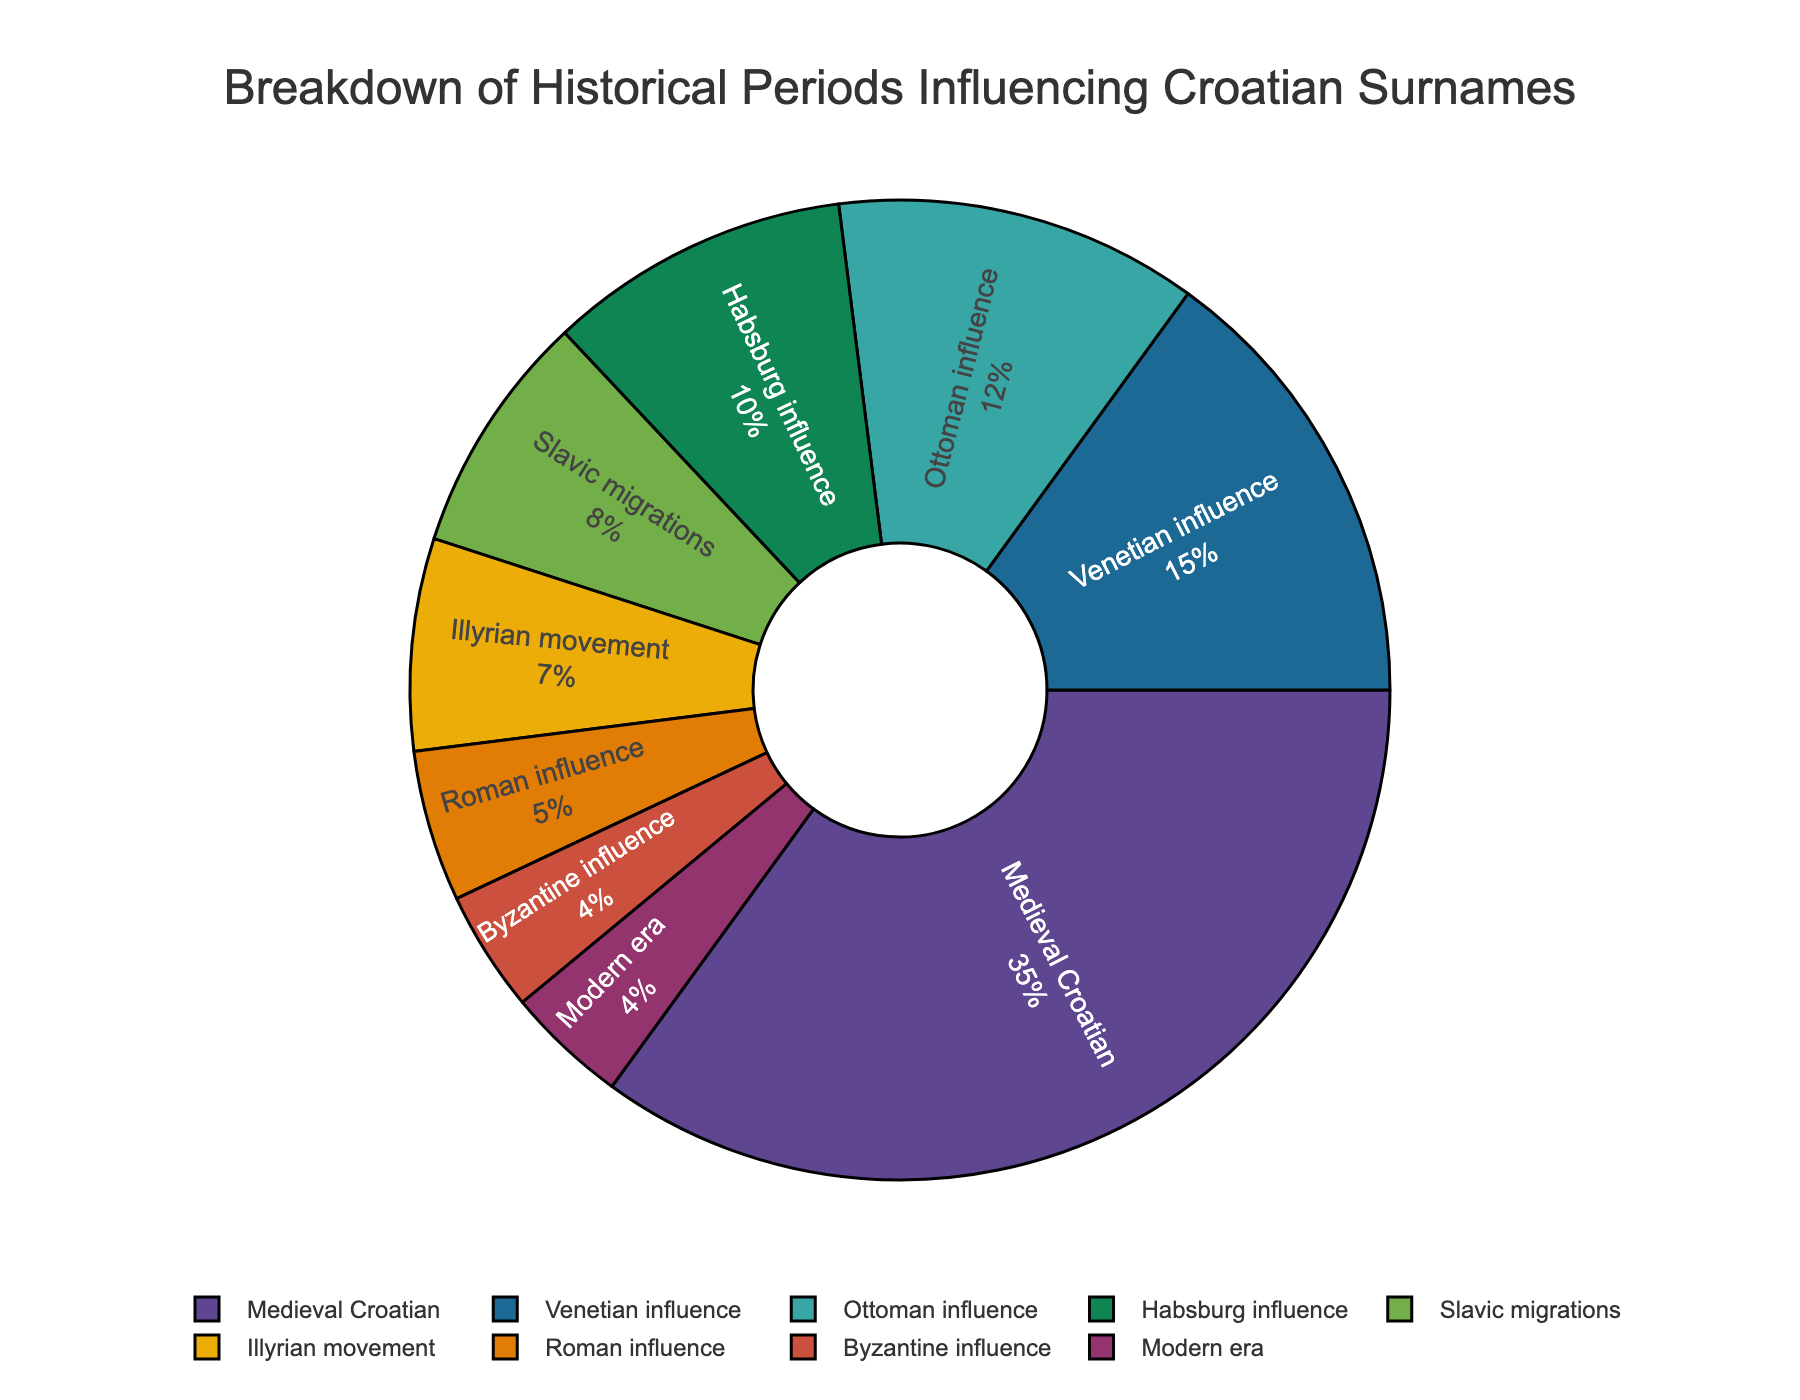Which period has the highest percentage influence on Croatian surnames? The Medieval Croatian period has the highest percentage, as it accounts for 35% of the influence on Croatian surnames. This value is the highest among all periods listed in the chart.
Answer: Medieval Croatian What is the combined percentage of influence from the Medieval Croatian and Ottoman periods? The Medieval Croatian period has a 35% influence, and the Ottoman influence is 12%. Adding these together gives 35% + 12% = 47%.
Answer: 47% Which period has a smaller influence: the Illyrian movement or Roman influence? The Roman influence has a smaller influence at 5%, compared to the Illyrian movement which has 7%.
Answer: Roman influence How much more influence does the Venetian period have compared to the Slavic migrations period? The Venetian influence is 15%, and the Slavic migrations influence is 8%. The difference is 15% - 8% = 7%.
Answer: 7% What is the total percentage influence of the periods identified as "Modern era" and "Byzantine influence"? The Modern era contributes 4%, and the Byzantine influence contributes 4%. Adding these two, 4% + 4% = 8%.
Answer: 8% Which period has the lowest influence, and what is its percentage? Both the Modern era and Byzantine influence have the lowest equal influence of 4%.
Answer: Modern era and Byzantine influence Compare the combined influence of Venetian and Habsburg periods to the combined influence of Slavic migrations and Illyrian movement periods. Which is higher and by how much? The combined influence of the Venetian and Habsburg periods is 15% + 10% = 25%. The combined influence of the Slavic migrations and Illyrian movement periods is 8% + 7% = 15%. The difference is 25% - 15% = 10%, with the Venetian and Habsburg combined influence being higher.
Answer: Venetian and Habsburg by 10% Which periods make up more than half of the total influence combined? The Medieval Croatian period (35%), Venetian influence (15%), and Ottoman influence (12%) together make 35% + 15% + 12% = 62%, which is more than half of the total influence.
Answer: Medieval Croatian, Venetian, Ottoman How does the influence of Habsburg compare to that of Byzantine influence? The Habsburg influence is 10%, while the Byzantine influence is 4%. The Habsburg influence is greater.
Answer: Habsburg What is the sum of influence by periods before and after the Medieval Croatian period marked on the chart? Before Medieval Croatian are Roman (5%) and Byzantine (4%), totaling 5% + 4% = 9%. After Medieval Croatian are Venetian (15%), Ottoman (12%), Habsburg (10%), Slavic migrations (8%), Illyrian movement (7%), Modern era (4%) adding up to 56%.
Answer: Before: 9%, After: 56% 